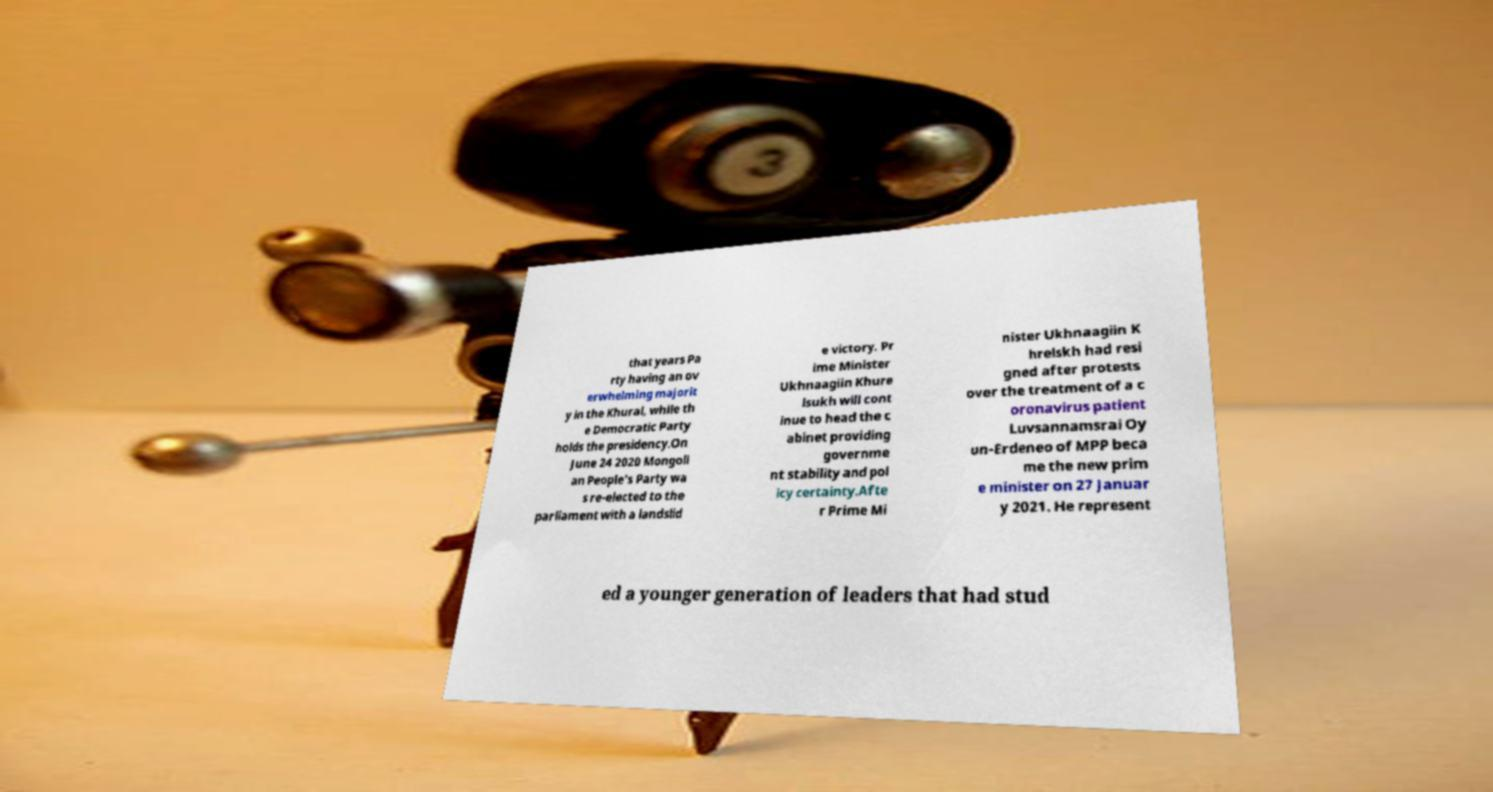Could you assist in decoding the text presented in this image and type it out clearly? that years Pa rty having an ov erwhelming majorit y in the Khural, while th e Democratic Party holds the presidency.On June 24 2020 Mongoli an People's Party wa s re-elected to the parliament with a landslid e victory. Pr ime Minister Ukhnaagiin Khure lsukh will cont inue to head the c abinet providing governme nt stability and pol icy certainty.Afte r Prime Mi nister Ukhnaagiin K hrelskh had resi gned after protests over the treatment of a c oronavirus patient Luvsannamsrai Oy un-Erdeneo of MPP beca me the new prim e minister on 27 Januar y 2021. He represent ed a younger generation of leaders that had stud 